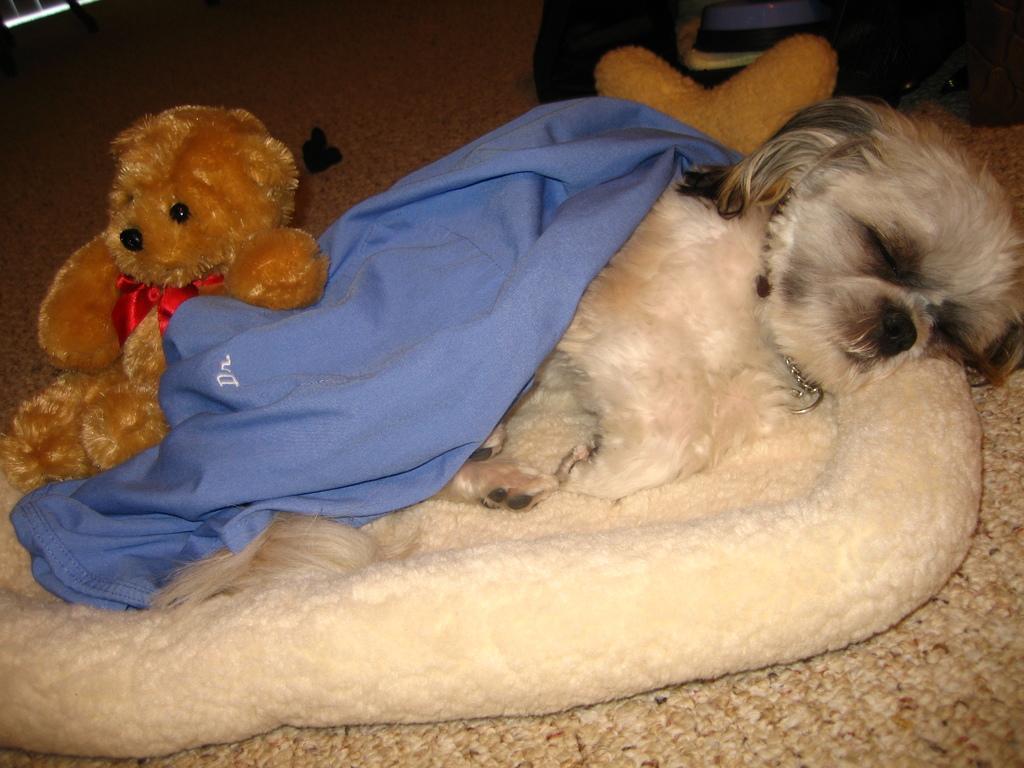Could you give a brief overview of what you see in this image? In this image in the center there is one dog which is sleeping, and on the left side there is one toy. At the bottom there is a furniture. 